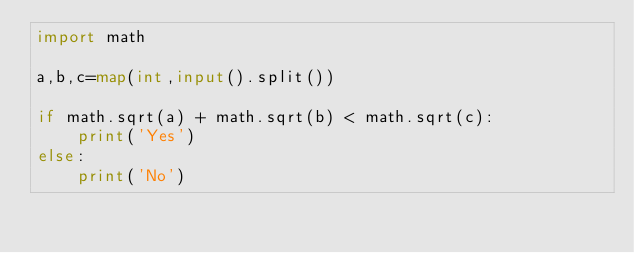<code> <loc_0><loc_0><loc_500><loc_500><_Python_>import math

a,b,c=map(int,input().split())

if math.sqrt(a) + math.sqrt(b) < math.sqrt(c):
    print('Yes')
else:
    print('No')
</code> 